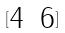Convert formula to latex. <formula><loc_0><loc_0><loc_500><loc_500>[ \begin{matrix} 4 & 6 \end{matrix} ]</formula> 